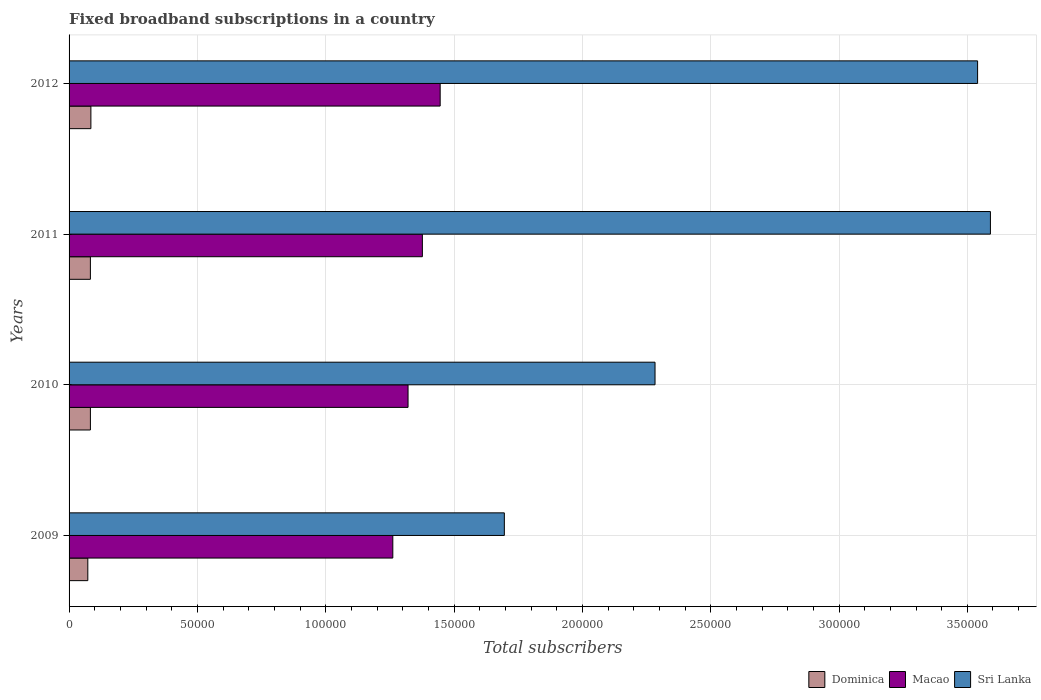How many different coloured bars are there?
Provide a succinct answer. 3. How many groups of bars are there?
Ensure brevity in your answer.  4. Are the number of bars per tick equal to the number of legend labels?
Give a very brief answer. Yes. How many bars are there on the 4th tick from the top?
Offer a terse response. 3. What is the label of the 1st group of bars from the top?
Your answer should be compact. 2012. What is the number of broadband subscriptions in Sri Lanka in 2011?
Your answer should be very brief. 3.59e+05. Across all years, what is the maximum number of broadband subscriptions in Macao?
Keep it short and to the point. 1.45e+05. Across all years, what is the minimum number of broadband subscriptions in Sri Lanka?
Your answer should be compact. 1.70e+05. In which year was the number of broadband subscriptions in Macao maximum?
Offer a very short reply. 2012. What is the total number of broadband subscriptions in Macao in the graph?
Make the answer very short. 5.40e+05. What is the difference between the number of broadband subscriptions in Sri Lanka in 2009 and that in 2012?
Your answer should be very brief. -1.84e+05. What is the difference between the number of broadband subscriptions in Dominica in 2011 and the number of broadband subscriptions in Macao in 2012?
Ensure brevity in your answer.  -1.36e+05. What is the average number of broadband subscriptions in Macao per year?
Your answer should be compact. 1.35e+05. In the year 2012, what is the difference between the number of broadband subscriptions in Macao and number of broadband subscriptions in Sri Lanka?
Keep it short and to the point. -2.09e+05. What is the ratio of the number of broadband subscriptions in Dominica in 2010 to that in 2012?
Ensure brevity in your answer.  0.98. Is the number of broadband subscriptions in Sri Lanka in 2009 less than that in 2010?
Make the answer very short. Yes. What is the difference between the highest and the second highest number of broadband subscriptions in Macao?
Keep it short and to the point. 6935. What is the difference between the highest and the lowest number of broadband subscriptions in Macao?
Ensure brevity in your answer.  1.85e+04. In how many years, is the number of broadband subscriptions in Dominica greater than the average number of broadband subscriptions in Dominica taken over all years?
Your answer should be compact. 3. Is the sum of the number of broadband subscriptions in Dominica in 2009 and 2010 greater than the maximum number of broadband subscriptions in Sri Lanka across all years?
Offer a very short reply. No. What does the 2nd bar from the top in 2010 represents?
Give a very brief answer. Macao. What does the 1st bar from the bottom in 2010 represents?
Give a very brief answer. Dominica. Is it the case that in every year, the sum of the number of broadband subscriptions in Dominica and number of broadband subscriptions in Sri Lanka is greater than the number of broadband subscriptions in Macao?
Provide a short and direct response. Yes. Are all the bars in the graph horizontal?
Ensure brevity in your answer.  Yes. How many years are there in the graph?
Offer a terse response. 4. What is the difference between two consecutive major ticks on the X-axis?
Keep it short and to the point. 5.00e+04. Does the graph contain grids?
Your response must be concise. Yes. Where does the legend appear in the graph?
Make the answer very short. Bottom right. How are the legend labels stacked?
Provide a succinct answer. Horizontal. What is the title of the graph?
Offer a terse response. Fixed broadband subscriptions in a country. What is the label or title of the X-axis?
Keep it short and to the point. Total subscribers. What is the Total subscribers in Dominica in 2009?
Your answer should be very brief. 7300. What is the Total subscribers of Macao in 2009?
Your answer should be compact. 1.26e+05. What is the Total subscribers in Sri Lanka in 2009?
Ensure brevity in your answer.  1.70e+05. What is the Total subscribers of Dominica in 2010?
Your response must be concise. 8311. What is the Total subscribers in Macao in 2010?
Offer a very short reply. 1.32e+05. What is the Total subscribers of Sri Lanka in 2010?
Keep it short and to the point. 2.28e+05. What is the Total subscribers of Dominica in 2011?
Give a very brief answer. 8307. What is the Total subscribers in Macao in 2011?
Your answer should be very brief. 1.38e+05. What is the Total subscribers in Sri Lanka in 2011?
Keep it short and to the point. 3.59e+05. What is the Total subscribers of Dominica in 2012?
Provide a succinct answer. 8500. What is the Total subscribers in Macao in 2012?
Keep it short and to the point. 1.45e+05. What is the Total subscribers of Sri Lanka in 2012?
Give a very brief answer. 3.54e+05. Across all years, what is the maximum Total subscribers of Dominica?
Ensure brevity in your answer.  8500. Across all years, what is the maximum Total subscribers in Macao?
Your answer should be very brief. 1.45e+05. Across all years, what is the maximum Total subscribers of Sri Lanka?
Offer a very short reply. 3.59e+05. Across all years, what is the minimum Total subscribers in Dominica?
Offer a very short reply. 7300. Across all years, what is the minimum Total subscribers of Macao?
Provide a short and direct response. 1.26e+05. Across all years, what is the minimum Total subscribers of Sri Lanka?
Your answer should be compact. 1.70e+05. What is the total Total subscribers in Dominica in the graph?
Give a very brief answer. 3.24e+04. What is the total Total subscribers in Macao in the graph?
Ensure brevity in your answer.  5.40e+05. What is the total Total subscribers in Sri Lanka in the graph?
Your answer should be very brief. 1.11e+06. What is the difference between the Total subscribers of Dominica in 2009 and that in 2010?
Make the answer very short. -1011. What is the difference between the Total subscribers in Macao in 2009 and that in 2010?
Offer a very short reply. -5939. What is the difference between the Total subscribers of Sri Lanka in 2009 and that in 2010?
Offer a terse response. -5.87e+04. What is the difference between the Total subscribers in Dominica in 2009 and that in 2011?
Offer a terse response. -1007. What is the difference between the Total subscribers in Macao in 2009 and that in 2011?
Make the answer very short. -1.15e+04. What is the difference between the Total subscribers of Sri Lanka in 2009 and that in 2011?
Provide a succinct answer. -1.89e+05. What is the difference between the Total subscribers of Dominica in 2009 and that in 2012?
Ensure brevity in your answer.  -1200. What is the difference between the Total subscribers of Macao in 2009 and that in 2012?
Give a very brief answer. -1.85e+04. What is the difference between the Total subscribers in Sri Lanka in 2009 and that in 2012?
Make the answer very short. -1.84e+05. What is the difference between the Total subscribers of Dominica in 2010 and that in 2011?
Your answer should be very brief. 4. What is the difference between the Total subscribers of Macao in 2010 and that in 2011?
Provide a short and direct response. -5580. What is the difference between the Total subscribers of Sri Lanka in 2010 and that in 2011?
Provide a short and direct response. -1.31e+05. What is the difference between the Total subscribers of Dominica in 2010 and that in 2012?
Offer a terse response. -189. What is the difference between the Total subscribers of Macao in 2010 and that in 2012?
Your answer should be very brief. -1.25e+04. What is the difference between the Total subscribers in Sri Lanka in 2010 and that in 2012?
Keep it short and to the point. -1.26e+05. What is the difference between the Total subscribers of Dominica in 2011 and that in 2012?
Your response must be concise. -193. What is the difference between the Total subscribers of Macao in 2011 and that in 2012?
Offer a very short reply. -6935. What is the difference between the Total subscribers in Dominica in 2009 and the Total subscribers in Macao in 2010?
Give a very brief answer. -1.25e+05. What is the difference between the Total subscribers in Dominica in 2009 and the Total subscribers in Sri Lanka in 2010?
Offer a terse response. -2.21e+05. What is the difference between the Total subscribers of Macao in 2009 and the Total subscribers of Sri Lanka in 2010?
Your answer should be compact. -1.02e+05. What is the difference between the Total subscribers of Dominica in 2009 and the Total subscribers of Macao in 2011?
Offer a very short reply. -1.30e+05. What is the difference between the Total subscribers in Dominica in 2009 and the Total subscribers in Sri Lanka in 2011?
Your answer should be compact. -3.52e+05. What is the difference between the Total subscribers of Macao in 2009 and the Total subscribers of Sri Lanka in 2011?
Ensure brevity in your answer.  -2.33e+05. What is the difference between the Total subscribers in Dominica in 2009 and the Total subscribers in Macao in 2012?
Provide a short and direct response. -1.37e+05. What is the difference between the Total subscribers of Dominica in 2009 and the Total subscribers of Sri Lanka in 2012?
Offer a very short reply. -3.47e+05. What is the difference between the Total subscribers in Macao in 2009 and the Total subscribers in Sri Lanka in 2012?
Offer a terse response. -2.28e+05. What is the difference between the Total subscribers in Dominica in 2010 and the Total subscribers in Macao in 2011?
Provide a short and direct response. -1.29e+05. What is the difference between the Total subscribers in Dominica in 2010 and the Total subscribers in Sri Lanka in 2011?
Offer a terse response. -3.51e+05. What is the difference between the Total subscribers in Macao in 2010 and the Total subscribers in Sri Lanka in 2011?
Give a very brief answer. -2.27e+05. What is the difference between the Total subscribers in Dominica in 2010 and the Total subscribers in Macao in 2012?
Provide a succinct answer. -1.36e+05. What is the difference between the Total subscribers in Dominica in 2010 and the Total subscribers in Sri Lanka in 2012?
Keep it short and to the point. -3.46e+05. What is the difference between the Total subscribers of Macao in 2010 and the Total subscribers of Sri Lanka in 2012?
Give a very brief answer. -2.22e+05. What is the difference between the Total subscribers of Dominica in 2011 and the Total subscribers of Macao in 2012?
Ensure brevity in your answer.  -1.36e+05. What is the difference between the Total subscribers of Dominica in 2011 and the Total subscribers of Sri Lanka in 2012?
Your answer should be compact. -3.46e+05. What is the difference between the Total subscribers of Macao in 2011 and the Total subscribers of Sri Lanka in 2012?
Your answer should be compact. -2.16e+05. What is the average Total subscribers in Dominica per year?
Your answer should be very brief. 8104.5. What is the average Total subscribers of Macao per year?
Your answer should be very brief. 1.35e+05. What is the average Total subscribers of Sri Lanka per year?
Your answer should be very brief. 2.78e+05. In the year 2009, what is the difference between the Total subscribers in Dominica and Total subscribers in Macao?
Provide a short and direct response. -1.19e+05. In the year 2009, what is the difference between the Total subscribers of Dominica and Total subscribers of Sri Lanka?
Offer a very short reply. -1.62e+05. In the year 2009, what is the difference between the Total subscribers of Macao and Total subscribers of Sri Lanka?
Provide a short and direct response. -4.35e+04. In the year 2010, what is the difference between the Total subscribers in Dominica and Total subscribers in Macao?
Your answer should be very brief. -1.24e+05. In the year 2010, what is the difference between the Total subscribers in Dominica and Total subscribers in Sri Lanka?
Provide a short and direct response. -2.20e+05. In the year 2010, what is the difference between the Total subscribers in Macao and Total subscribers in Sri Lanka?
Provide a short and direct response. -9.62e+04. In the year 2011, what is the difference between the Total subscribers of Dominica and Total subscribers of Macao?
Your response must be concise. -1.29e+05. In the year 2011, what is the difference between the Total subscribers in Dominica and Total subscribers in Sri Lanka?
Give a very brief answer. -3.51e+05. In the year 2011, what is the difference between the Total subscribers of Macao and Total subscribers of Sri Lanka?
Keep it short and to the point. -2.21e+05. In the year 2012, what is the difference between the Total subscribers in Dominica and Total subscribers in Macao?
Your answer should be very brief. -1.36e+05. In the year 2012, what is the difference between the Total subscribers in Dominica and Total subscribers in Sri Lanka?
Keep it short and to the point. -3.46e+05. In the year 2012, what is the difference between the Total subscribers in Macao and Total subscribers in Sri Lanka?
Offer a terse response. -2.09e+05. What is the ratio of the Total subscribers in Dominica in 2009 to that in 2010?
Provide a succinct answer. 0.88. What is the ratio of the Total subscribers of Macao in 2009 to that in 2010?
Your answer should be compact. 0.95. What is the ratio of the Total subscribers of Sri Lanka in 2009 to that in 2010?
Your answer should be very brief. 0.74. What is the ratio of the Total subscribers of Dominica in 2009 to that in 2011?
Your response must be concise. 0.88. What is the ratio of the Total subscribers of Macao in 2009 to that in 2011?
Offer a terse response. 0.92. What is the ratio of the Total subscribers in Sri Lanka in 2009 to that in 2011?
Your answer should be compact. 0.47. What is the ratio of the Total subscribers in Dominica in 2009 to that in 2012?
Ensure brevity in your answer.  0.86. What is the ratio of the Total subscribers in Macao in 2009 to that in 2012?
Your response must be concise. 0.87. What is the ratio of the Total subscribers in Sri Lanka in 2009 to that in 2012?
Provide a succinct answer. 0.48. What is the ratio of the Total subscribers of Macao in 2010 to that in 2011?
Make the answer very short. 0.96. What is the ratio of the Total subscribers of Sri Lanka in 2010 to that in 2011?
Make the answer very short. 0.64. What is the ratio of the Total subscribers in Dominica in 2010 to that in 2012?
Ensure brevity in your answer.  0.98. What is the ratio of the Total subscribers in Macao in 2010 to that in 2012?
Keep it short and to the point. 0.91. What is the ratio of the Total subscribers in Sri Lanka in 2010 to that in 2012?
Provide a short and direct response. 0.65. What is the ratio of the Total subscribers of Dominica in 2011 to that in 2012?
Offer a terse response. 0.98. What is the ratio of the Total subscribers in Sri Lanka in 2011 to that in 2012?
Provide a succinct answer. 1.01. What is the difference between the highest and the second highest Total subscribers in Dominica?
Offer a very short reply. 189. What is the difference between the highest and the second highest Total subscribers of Macao?
Offer a terse response. 6935. What is the difference between the highest and the lowest Total subscribers in Dominica?
Your answer should be very brief. 1200. What is the difference between the highest and the lowest Total subscribers in Macao?
Your answer should be very brief. 1.85e+04. What is the difference between the highest and the lowest Total subscribers in Sri Lanka?
Offer a very short reply. 1.89e+05. 